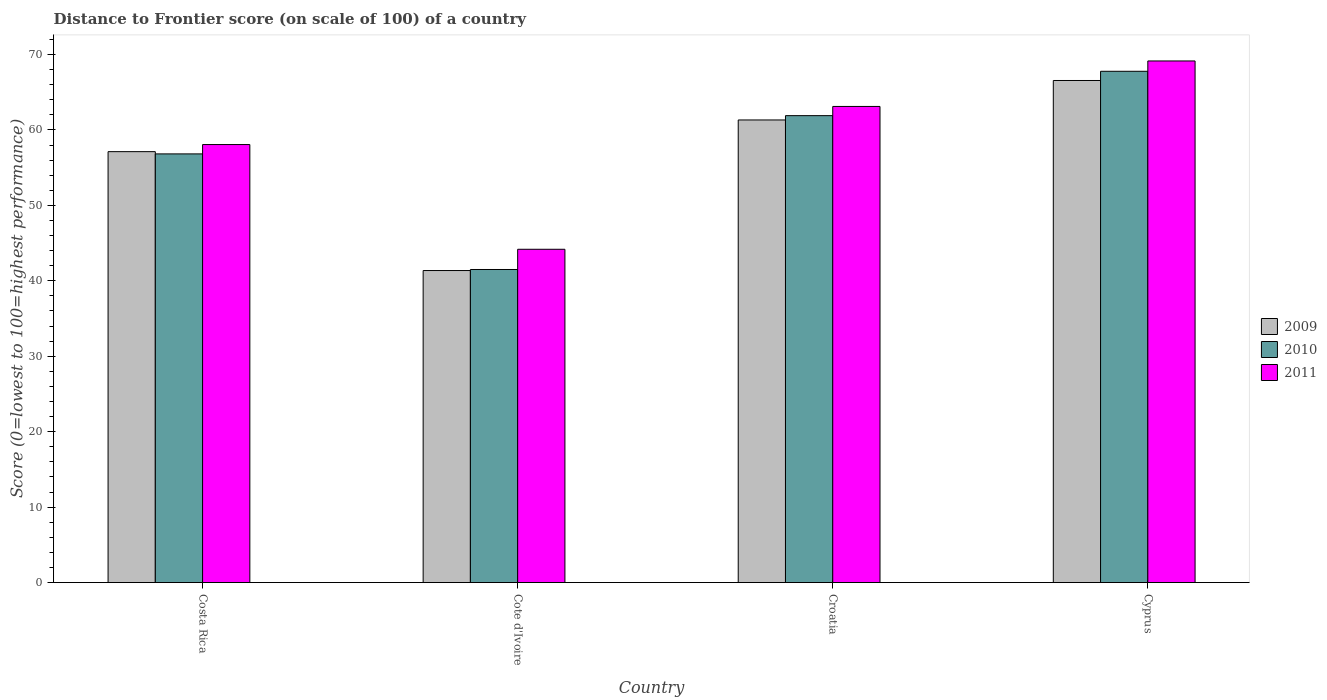How many different coloured bars are there?
Your answer should be compact. 3. Are the number of bars per tick equal to the number of legend labels?
Keep it short and to the point. Yes. Are the number of bars on each tick of the X-axis equal?
Make the answer very short. Yes. How many bars are there on the 3rd tick from the right?
Your response must be concise. 3. What is the label of the 4th group of bars from the left?
Offer a terse response. Cyprus. What is the distance to frontier score of in 2009 in Croatia?
Offer a terse response. 61.32. Across all countries, what is the maximum distance to frontier score of in 2010?
Offer a terse response. 67.77. Across all countries, what is the minimum distance to frontier score of in 2009?
Keep it short and to the point. 41.36. In which country was the distance to frontier score of in 2011 maximum?
Ensure brevity in your answer.  Cyprus. In which country was the distance to frontier score of in 2009 minimum?
Keep it short and to the point. Cote d'Ivoire. What is the total distance to frontier score of in 2010 in the graph?
Ensure brevity in your answer.  227.98. What is the difference between the distance to frontier score of in 2010 in Croatia and that in Cyprus?
Keep it short and to the point. -5.88. What is the difference between the distance to frontier score of in 2009 in Croatia and the distance to frontier score of in 2011 in Cyprus?
Make the answer very short. -7.82. What is the average distance to frontier score of in 2011 per country?
Offer a terse response. 58.62. What is the difference between the distance to frontier score of of/in 2010 and distance to frontier score of of/in 2009 in Croatia?
Keep it short and to the point. 0.57. What is the ratio of the distance to frontier score of in 2011 in Costa Rica to that in Cyprus?
Ensure brevity in your answer.  0.84. Is the difference between the distance to frontier score of in 2010 in Cote d'Ivoire and Croatia greater than the difference between the distance to frontier score of in 2009 in Cote d'Ivoire and Croatia?
Your answer should be very brief. No. What is the difference between the highest and the second highest distance to frontier score of in 2011?
Your response must be concise. -11.08. What is the difference between the highest and the lowest distance to frontier score of in 2010?
Provide a succinct answer. 26.27. In how many countries, is the distance to frontier score of in 2011 greater than the average distance to frontier score of in 2011 taken over all countries?
Offer a terse response. 2. Is the sum of the distance to frontier score of in 2011 in Costa Rica and Cote d'Ivoire greater than the maximum distance to frontier score of in 2010 across all countries?
Provide a short and direct response. Yes. What does the 1st bar from the right in Cote d'Ivoire represents?
Ensure brevity in your answer.  2011. Is it the case that in every country, the sum of the distance to frontier score of in 2010 and distance to frontier score of in 2009 is greater than the distance to frontier score of in 2011?
Your answer should be very brief. Yes. Are all the bars in the graph horizontal?
Ensure brevity in your answer.  No. What is the difference between two consecutive major ticks on the Y-axis?
Make the answer very short. 10. Are the values on the major ticks of Y-axis written in scientific E-notation?
Provide a succinct answer. No. Does the graph contain any zero values?
Ensure brevity in your answer.  No. What is the title of the graph?
Provide a short and direct response. Distance to Frontier score (on scale of 100) of a country. Does "2001" appear as one of the legend labels in the graph?
Provide a short and direct response. No. What is the label or title of the Y-axis?
Offer a very short reply. Score (0=lowest to 100=highest performance). What is the Score (0=lowest to 100=highest performance) in 2009 in Costa Rica?
Ensure brevity in your answer.  57.12. What is the Score (0=lowest to 100=highest performance) in 2010 in Costa Rica?
Your response must be concise. 56.82. What is the Score (0=lowest to 100=highest performance) in 2011 in Costa Rica?
Provide a short and direct response. 58.06. What is the Score (0=lowest to 100=highest performance) of 2009 in Cote d'Ivoire?
Make the answer very short. 41.36. What is the Score (0=lowest to 100=highest performance) of 2010 in Cote d'Ivoire?
Your answer should be compact. 41.5. What is the Score (0=lowest to 100=highest performance) in 2011 in Cote d'Ivoire?
Your answer should be compact. 44.18. What is the Score (0=lowest to 100=highest performance) of 2009 in Croatia?
Offer a terse response. 61.32. What is the Score (0=lowest to 100=highest performance) in 2010 in Croatia?
Keep it short and to the point. 61.89. What is the Score (0=lowest to 100=highest performance) in 2011 in Croatia?
Offer a terse response. 63.11. What is the Score (0=lowest to 100=highest performance) in 2009 in Cyprus?
Offer a terse response. 66.55. What is the Score (0=lowest to 100=highest performance) in 2010 in Cyprus?
Give a very brief answer. 67.77. What is the Score (0=lowest to 100=highest performance) in 2011 in Cyprus?
Offer a very short reply. 69.14. Across all countries, what is the maximum Score (0=lowest to 100=highest performance) in 2009?
Make the answer very short. 66.55. Across all countries, what is the maximum Score (0=lowest to 100=highest performance) in 2010?
Make the answer very short. 67.77. Across all countries, what is the maximum Score (0=lowest to 100=highest performance) in 2011?
Offer a terse response. 69.14. Across all countries, what is the minimum Score (0=lowest to 100=highest performance) in 2009?
Offer a very short reply. 41.36. Across all countries, what is the minimum Score (0=lowest to 100=highest performance) in 2010?
Offer a very short reply. 41.5. Across all countries, what is the minimum Score (0=lowest to 100=highest performance) of 2011?
Provide a short and direct response. 44.18. What is the total Score (0=lowest to 100=highest performance) of 2009 in the graph?
Your answer should be compact. 226.35. What is the total Score (0=lowest to 100=highest performance) of 2010 in the graph?
Offer a terse response. 227.98. What is the total Score (0=lowest to 100=highest performance) in 2011 in the graph?
Your answer should be compact. 234.49. What is the difference between the Score (0=lowest to 100=highest performance) of 2009 in Costa Rica and that in Cote d'Ivoire?
Offer a terse response. 15.76. What is the difference between the Score (0=lowest to 100=highest performance) of 2010 in Costa Rica and that in Cote d'Ivoire?
Provide a short and direct response. 15.32. What is the difference between the Score (0=lowest to 100=highest performance) of 2011 in Costa Rica and that in Cote d'Ivoire?
Your answer should be compact. 13.88. What is the difference between the Score (0=lowest to 100=highest performance) in 2010 in Costa Rica and that in Croatia?
Keep it short and to the point. -5.07. What is the difference between the Score (0=lowest to 100=highest performance) of 2011 in Costa Rica and that in Croatia?
Your answer should be compact. -5.05. What is the difference between the Score (0=lowest to 100=highest performance) of 2009 in Costa Rica and that in Cyprus?
Make the answer very short. -9.43. What is the difference between the Score (0=lowest to 100=highest performance) of 2010 in Costa Rica and that in Cyprus?
Your response must be concise. -10.95. What is the difference between the Score (0=lowest to 100=highest performance) of 2011 in Costa Rica and that in Cyprus?
Provide a short and direct response. -11.08. What is the difference between the Score (0=lowest to 100=highest performance) of 2009 in Cote d'Ivoire and that in Croatia?
Your response must be concise. -19.96. What is the difference between the Score (0=lowest to 100=highest performance) of 2010 in Cote d'Ivoire and that in Croatia?
Your response must be concise. -20.39. What is the difference between the Score (0=lowest to 100=highest performance) in 2011 in Cote d'Ivoire and that in Croatia?
Make the answer very short. -18.93. What is the difference between the Score (0=lowest to 100=highest performance) of 2009 in Cote d'Ivoire and that in Cyprus?
Keep it short and to the point. -25.19. What is the difference between the Score (0=lowest to 100=highest performance) of 2010 in Cote d'Ivoire and that in Cyprus?
Make the answer very short. -26.27. What is the difference between the Score (0=lowest to 100=highest performance) in 2011 in Cote d'Ivoire and that in Cyprus?
Your answer should be compact. -24.96. What is the difference between the Score (0=lowest to 100=highest performance) of 2009 in Croatia and that in Cyprus?
Your response must be concise. -5.23. What is the difference between the Score (0=lowest to 100=highest performance) in 2010 in Croatia and that in Cyprus?
Your answer should be compact. -5.88. What is the difference between the Score (0=lowest to 100=highest performance) in 2011 in Croatia and that in Cyprus?
Ensure brevity in your answer.  -6.03. What is the difference between the Score (0=lowest to 100=highest performance) of 2009 in Costa Rica and the Score (0=lowest to 100=highest performance) of 2010 in Cote d'Ivoire?
Your answer should be very brief. 15.62. What is the difference between the Score (0=lowest to 100=highest performance) in 2009 in Costa Rica and the Score (0=lowest to 100=highest performance) in 2011 in Cote d'Ivoire?
Provide a short and direct response. 12.94. What is the difference between the Score (0=lowest to 100=highest performance) in 2010 in Costa Rica and the Score (0=lowest to 100=highest performance) in 2011 in Cote d'Ivoire?
Offer a very short reply. 12.64. What is the difference between the Score (0=lowest to 100=highest performance) of 2009 in Costa Rica and the Score (0=lowest to 100=highest performance) of 2010 in Croatia?
Make the answer very short. -4.77. What is the difference between the Score (0=lowest to 100=highest performance) in 2009 in Costa Rica and the Score (0=lowest to 100=highest performance) in 2011 in Croatia?
Offer a very short reply. -5.99. What is the difference between the Score (0=lowest to 100=highest performance) in 2010 in Costa Rica and the Score (0=lowest to 100=highest performance) in 2011 in Croatia?
Keep it short and to the point. -6.29. What is the difference between the Score (0=lowest to 100=highest performance) of 2009 in Costa Rica and the Score (0=lowest to 100=highest performance) of 2010 in Cyprus?
Your response must be concise. -10.65. What is the difference between the Score (0=lowest to 100=highest performance) of 2009 in Costa Rica and the Score (0=lowest to 100=highest performance) of 2011 in Cyprus?
Your answer should be compact. -12.02. What is the difference between the Score (0=lowest to 100=highest performance) in 2010 in Costa Rica and the Score (0=lowest to 100=highest performance) in 2011 in Cyprus?
Provide a succinct answer. -12.32. What is the difference between the Score (0=lowest to 100=highest performance) in 2009 in Cote d'Ivoire and the Score (0=lowest to 100=highest performance) in 2010 in Croatia?
Offer a very short reply. -20.53. What is the difference between the Score (0=lowest to 100=highest performance) of 2009 in Cote d'Ivoire and the Score (0=lowest to 100=highest performance) of 2011 in Croatia?
Keep it short and to the point. -21.75. What is the difference between the Score (0=lowest to 100=highest performance) of 2010 in Cote d'Ivoire and the Score (0=lowest to 100=highest performance) of 2011 in Croatia?
Make the answer very short. -21.61. What is the difference between the Score (0=lowest to 100=highest performance) of 2009 in Cote d'Ivoire and the Score (0=lowest to 100=highest performance) of 2010 in Cyprus?
Give a very brief answer. -26.41. What is the difference between the Score (0=lowest to 100=highest performance) in 2009 in Cote d'Ivoire and the Score (0=lowest to 100=highest performance) in 2011 in Cyprus?
Provide a succinct answer. -27.78. What is the difference between the Score (0=lowest to 100=highest performance) of 2010 in Cote d'Ivoire and the Score (0=lowest to 100=highest performance) of 2011 in Cyprus?
Keep it short and to the point. -27.64. What is the difference between the Score (0=lowest to 100=highest performance) in 2009 in Croatia and the Score (0=lowest to 100=highest performance) in 2010 in Cyprus?
Provide a succinct answer. -6.45. What is the difference between the Score (0=lowest to 100=highest performance) in 2009 in Croatia and the Score (0=lowest to 100=highest performance) in 2011 in Cyprus?
Your answer should be very brief. -7.82. What is the difference between the Score (0=lowest to 100=highest performance) in 2010 in Croatia and the Score (0=lowest to 100=highest performance) in 2011 in Cyprus?
Your response must be concise. -7.25. What is the average Score (0=lowest to 100=highest performance) in 2009 per country?
Provide a succinct answer. 56.59. What is the average Score (0=lowest to 100=highest performance) of 2010 per country?
Your response must be concise. 56.99. What is the average Score (0=lowest to 100=highest performance) in 2011 per country?
Give a very brief answer. 58.62. What is the difference between the Score (0=lowest to 100=highest performance) of 2009 and Score (0=lowest to 100=highest performance) of 2010 in Costa Rica?
Give a very brief answer. 0.3. What is the difference between the Score (0=lowest to 100=highest performance) of 2009 and Score (0=lowest to 100=highest performance) of 2011 in Costa Rica?
Your response must be concise. -0.94. What is the difference between the Score (0=lowest to 100=highest performance) in 2010 and Score (0=lowest to 100=highest performance) in 2011 in Costa Rica?
Provide a succinct answer. -1.24. What is the difference between the Score (0=lowest to 100=highest performance) of 2009 and Score (0=lowest to 100=highest performance) of 2010 in Cote d'Ivoire?
Provide a succinct answer. -0.14. What is the difference between the Score (0=lowest to 100=highest performance) in 2009 and Score (0=lowest to 100=highest performance) in 2011 in Cote d'Ivoire?
Your response must be concise. -2.82. What is the difference between the Score (0=lowest to 100=highest performance) of 2010 and Score (0=lowest to 100=highest performance) of 2011 in Cote d'Ivoire?
Your answer should be very brief. -2.68. What is the difference between the Score (0=lowest to 100=highest performance) of 2009 and Score (0=lowest to 100=highest performance) of 2010 in Croatia?
Your answer should be very brief. -0.57. What is the difference between the Score (0=lowest to 100=highest performance) of 2009 and Score (0=lowest to 100=highest performance) of 2011 in Croatia?
Your answer should be very brief. -1.79. What is the difference between the Score (0=lowest to 100=highest performance) in 2010 and Score (0=lowest to 100=highest performance) in 2011 in Croatia?
Provide a succinct answer. -1.22. What is the difference between the Score (0=lowest to 100=highest performance) in 2009 and Score (0=lowest to 100=highest performance) in 2010 in Cyprus?
Your answer should be compact. -1.22. What is the difference between the Score (0=lowest to 100=highest performance) in 2009 and Score (0=lowest to 100=highest performance) in 2011 in Cyprus?
Your answer should be very brief. -2.59. What is the difference between the Score (0=lowest to 100=highest performance) in 2010 and Score (0=lowest to 100=highest performance) in 2011 in Cyprus?
Offer a very short reply. -1.37. What is the ratio of the Score (0=lowest to 100=highest performance) of 2009 in Costa Rica to that in Cote d'Ivoire?
Give a very brief answer. 1.38. What is the ratio of the Score (0=lowest to 100=highest performance) of 2010 in Costa Rica to that in Cote d'Ivoire?
Provide a succinct answer. 1.37. What is the ratio of the Score (0=lowest to 100=highest performance) in 2011 in Costa Rica to that in Cote d'Ivoire?
Your answer should be compact. 1.31. What is the ratio of the Score (0=lowest to 100=highest performance) of 2009 in Costa Rica to that in Croatia?
Your response must be concise. 0.93. What is the ratio of the Score (0=lowest to 100=highest performance) of 2010 in Costa Rica to that in Croatia?
Keep it short and to the point. 0.92. What is the ratio of the Score (0=lowest to 100=highest performance) in 2009 in Costa Rica to that in Cyprus?
Offer a terse response. 0.86. What is the ratio of the Score (0=lowest to 100=highest performance) in 2010 in Costa Rica to that in Cyprus?
Your answer should be very brief. 0.84. What is the ratio of the Score (0=lowest to 100=highest performance) in 2011 in Costa Rica to that in Cyprus?
Your answer should be compact. 0.84. What is the ratio of the Score (0=lowest to 100=highest performance) in 2009 in Cote d'Ivoire to that in Croatia?
Make the answer very short. 0.67. What is the ratio of the Score (0=lowest to 100=highest performance) of 2010 in Cote d'Ivoire to that in Croatia?
Your response must be concise. 0.67. What is the ratio of the Score (0=lowest to 100=highest performance) in 2009 in Cote d'Ivoire to that in Cyprus?
Offer a terse response. 0.62. What is the ratio of the Score (0=lowest to 100=highest performance) in 2010 in Cote d'Ivoire to that in Cyprus?
Your response must be concise. 0.61. What is the ratio of the Score (0=lowest to 100=highest performance) in 2011 in Cote d'Ivoire to that in Cyprus?
Offer a very short reply. 0.64. What is the ratio of the Score (0=lowest to 100=highest performance) in 2009 in Croatia to that in Cyprus?
Give a very brief answer. 0.92. What is the ratio of the Score (0=lowest to 100=highest performance) in 2010 in Croatia to that in Cyprus?
Give a very brief answer. 0.91. What is the ratio of the Score (0=lowest to 100=highest performance) of 2011 in Croatia to that in Cyprus?
Your answer should be very brief. 0.91. What is the difference between the highest and the second highest Score (0=lowest to 100=highest performance) of 2009?
Keep it short and to the point. 5.23. What is the difference between the highest and the second highest Score (0=lowest to 100=highest performance) in 2010?
Your response must be concise. 5.88. What is the difference between the highest and the second highest Score (0=lowest to 100=highest performance) of 2011?
Provide a short and direct response. 6.03. What is the difference between the highest and the lowest Score (0=lowest to 100=highest performance) in 2009?
Your response must be concise. 25.19. What is the difference between the highest and the lowest Score (0=lowest to 100=highest performance) of 2010?
Your answer should be very brief. 26.27. What is the difference between the highest and the lowest Score (0=lowest to 100=highest performance) of 2011?
Keep it short and to the point. 24.96. 